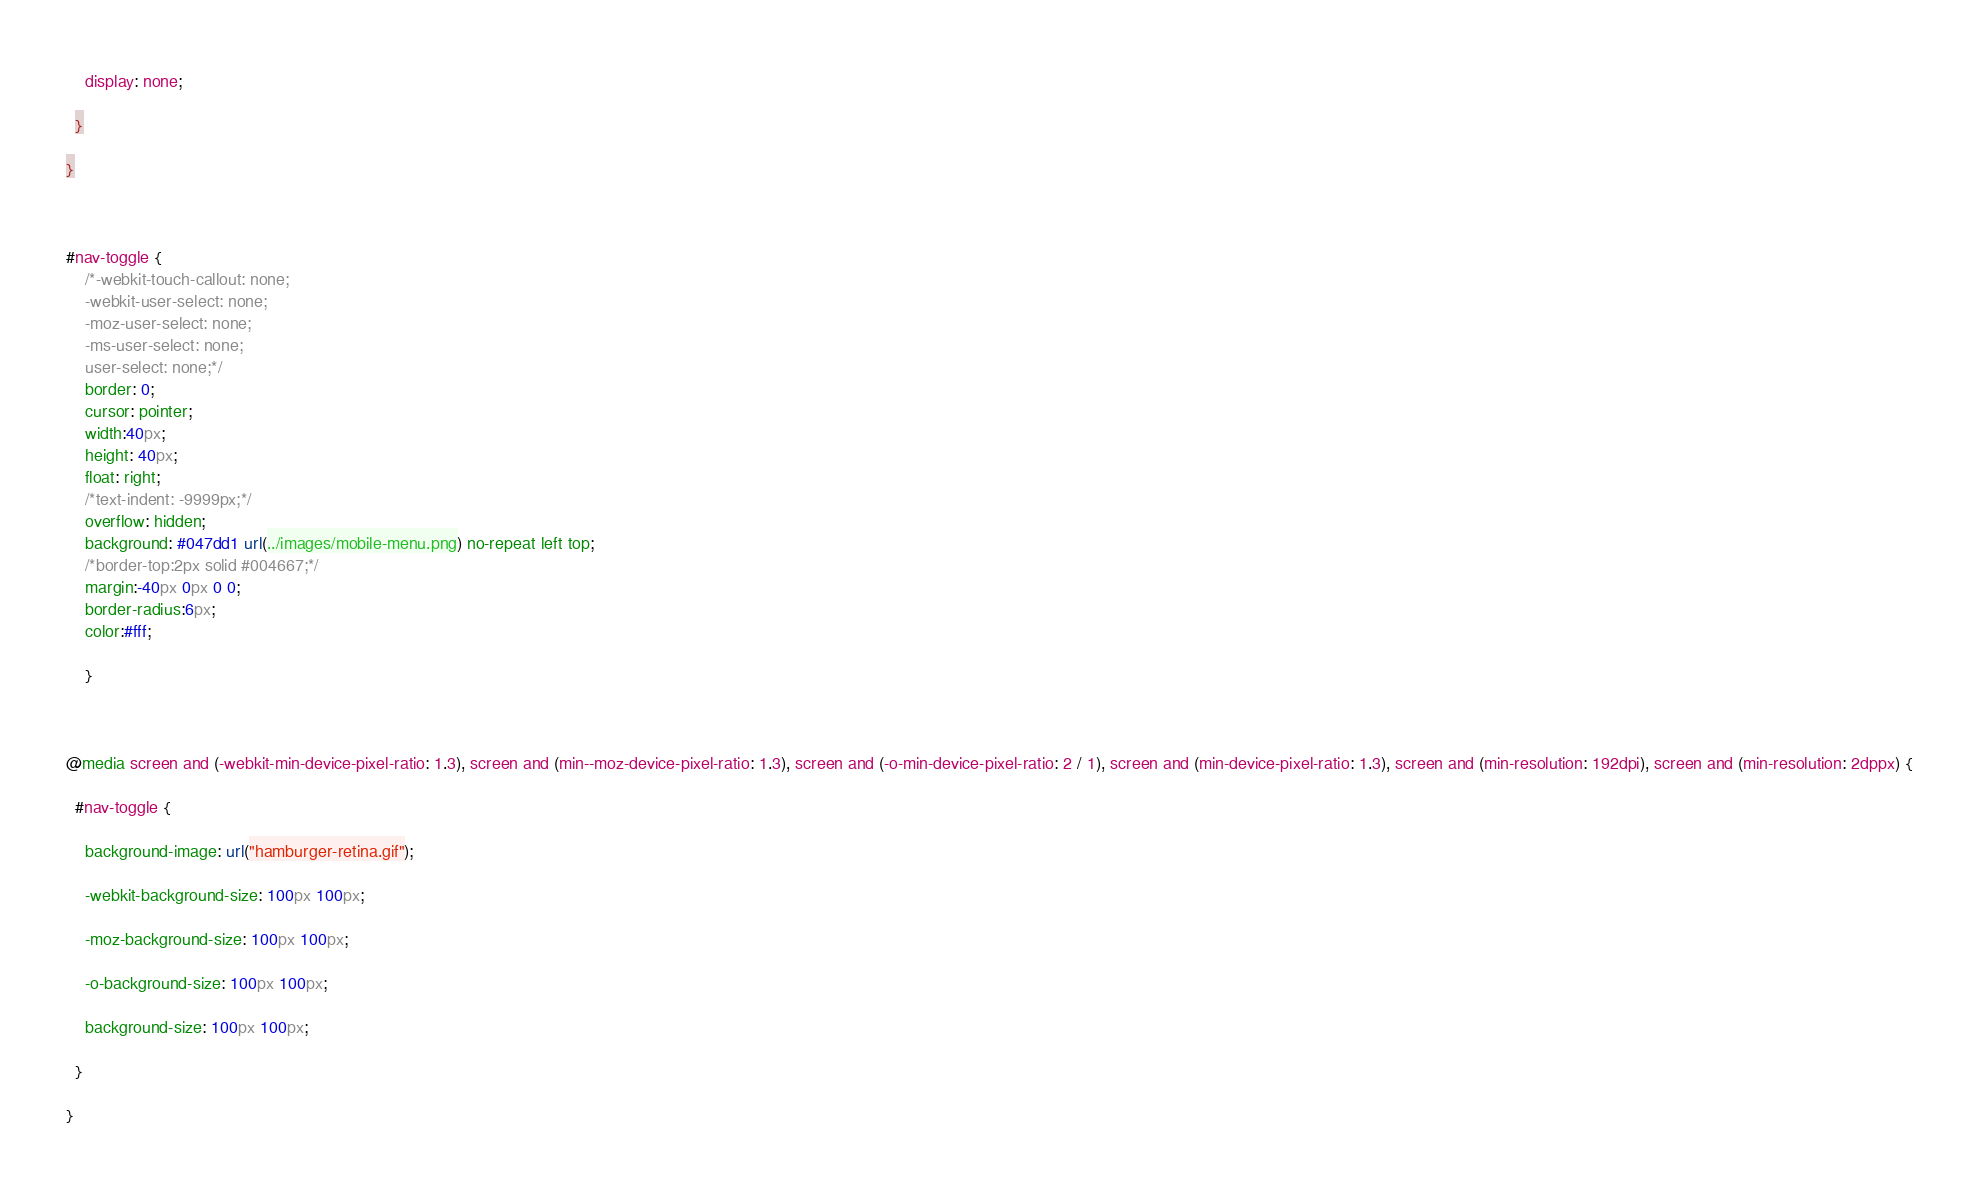Convert code to text. <code><loc_0><loc_0><loc_500><loc_500><_CSS_>
    display: none;

  }

}



#nav-toggle {
	/*-webkit-touch-callout: none;
	-webkit-user-select: none;
	-moz-user-select: none;
	-ms-user-select: none;
	user-select: none;*/
	border: 0;
	cursor: pointer;
	width:40px;
	height: 40px;
	float: right;
	/*text-indent: -9999px;*/
	overflow: hidden;
	background: #047dd1 url(../images/mobile-menu.png) no-repeat left top;
	/*border-top:2px solid #004667;*/
	margin:-40px 0px 0 0;
	border-radius:6px;
	color:#fff;

	}



@media screen and (-webkit-min-device-pixel-ratio: 1.3), screen and (min--moz-device-pixel-ratio: 1.3), screen and (-o-min-device-pixel-ratio: 2 / 1), screen and (min-device-pixel-ratio: 1.3), screen and (min-resolution: 192dpi), screen and (min-resolution: 2dppx) {

  #nav-toggle {

    background-image: url("hamburger-retina.gif");

    -webkit-background-size: 100px 100px;

    -moz-background-size: 100px 100px;

    -o-background-size: 100px 100px;

    background-size: 100px 100px;

  }

}

</code> 